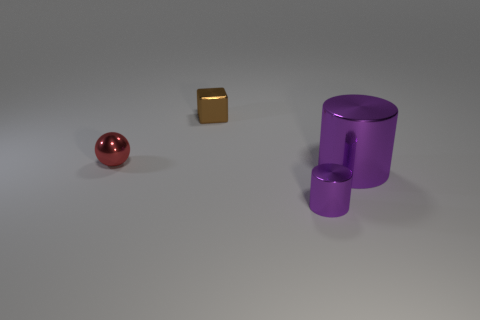Add 1 tiny red metal spheres. How many objects exist? 5 Subtract 1 cylinders. How many cylinders are left? 1 Subtract all cubes. How many objects are left? 3 Subtract all gray balls. Subtract all cyan cylinders. How many balls are left? 1 Subtract all tiny cyan rubber things. Subtract all tiny metallic balls. How many objects are left? 3 Add 2 big purple cylinders. How many big purple cylinders are left? 3 Add 4 tiny metallic cylinders. How many tiny metallic cylinders exist? 5 Subtract 1 brown blocks. How many objects are left? 3 